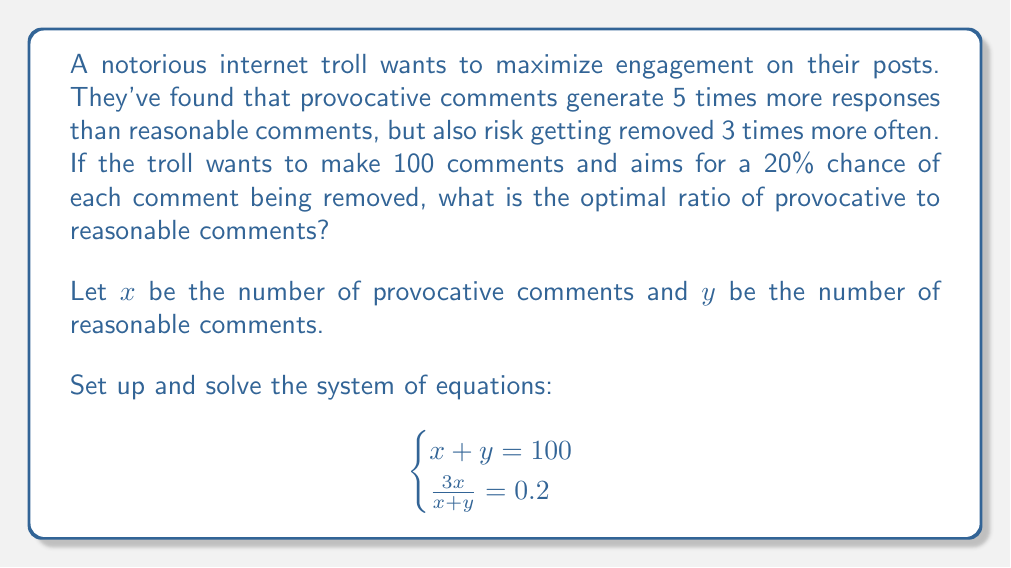Could you help me with this problem? Let's solve this system of equations step by step:

1) From the first equation, we know:
   $x + y = 100$ ... (1)

2) The second equation represents the probability of a comment being removed:
   $\frac{3x}{x+y} = 0.2$

3) Substitute (1) into this equation:
   $\frac{3x}{100} = 0.2$

4) Solve for $x$:
   $3x = 20$
   $x = \frac{20}{3} \approx 6.67$

5) Round $x$ to the nearest whole number: $x = 7$

6) Substitute this back into equation (1) to find $y$:
   $7 + y = 100$
   $y = 93$

7) The ratio of provocative to reasonable comments is therefore 7:93, which can be simplified to 1:13.29

8) To express this as a single number, divide provocative by total:
   $\frac{7}{100} = 0.07$ or 7%

Therefore, the optimal ratio is 7% provocative comments to 93% reasonable comments.
Answer: The optimal ratio is 7% provocative comments to 93% reasonable comments, or approximately 1:13.29. 